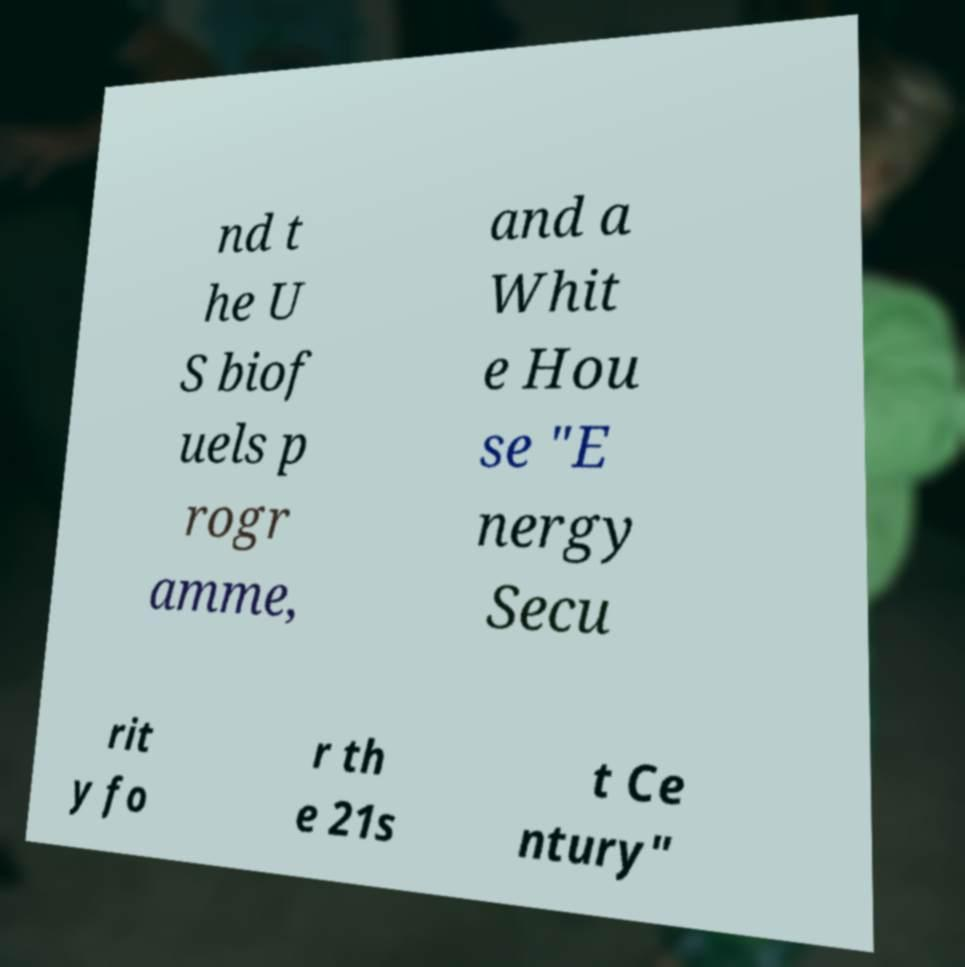I need the written content from this picture converted into text. Can you do that? nd t he U S biof uels p rogr amme, and a Whit e Hou se "E nergy Secu rit y fo r th e 21s t Ce ntury" 